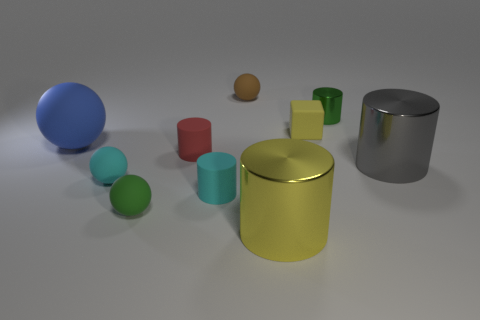What materials do the objects in the image appear to be made of? The objects in the image seem to exhibit a variety of textures suggesting different materials. The matte finish on the red and green objects hints at a plastic or painted wood, while the blue and gray objects with reflective surfaces may represent materials like metal or polished stone. The yellow object's slight sheen could indicate a material like brushed metal or anodized aluminum. 